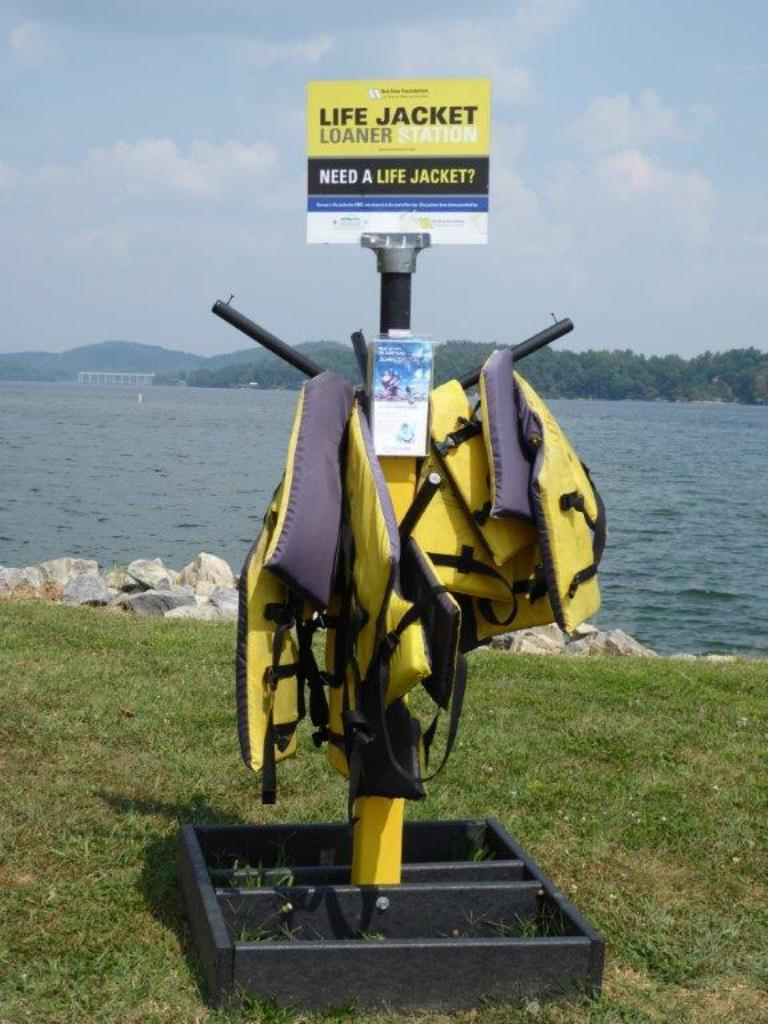What body of water is present in the image? There is a lake in the image. What can be seen in the sky in the image? There are clouds visible in the image. What type of vegetation is in the background of the image? There are trees in the background of the image. What is being used to hold jackets in the image? There is a stand holding jackets in the image. What type of patch is visible on the lake in the image? There is no patch visible on the lake in the image. 